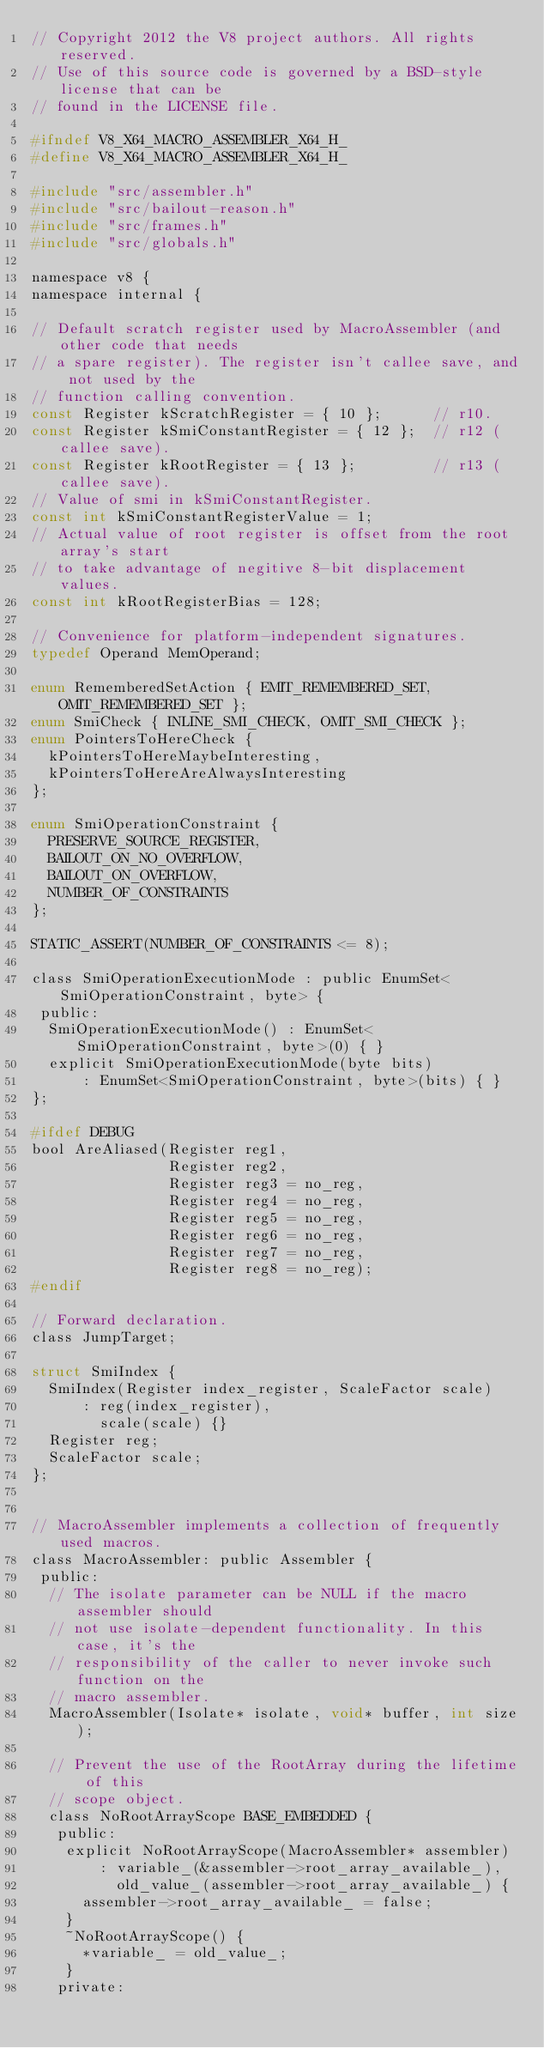Convert code to text. <code><loc_0><loc_0><loc_500><loc_500><_C_>// Copyright 2012 the V8 project authors. All rights reserved.
// Use of this source code is governed by a BSD-style license that can be
// found in the LICENSE file.

#ifndef V8_X64_MACRO_ASSEMBLER_X64_H_
#define V8_X64_MACRO_ASSEMBLER_X64_H_

#include "src/assembler.h"
#include "src/bailout-reason.h"
#include "src/frames.h"
#include "src/globals.h"

namespace v8 {
namespace internal {

// Default scratch register used by MacroAssembler (and other code that needs
// a spare register). The register isn't callee save, and not used by the
// function calling convention.
const Register kScratchRegister = { 10 };      // r10.
const Register kSmiConstantRegister = { 12 };  // r12 (callee save).
const Register kRootRegister = { 13 };         // r13 (callee save).
// Value of smi in kSmiConstantRegister.
const int kSmiConstantRegisterValue = 1;
// Actual value of root register is offset from the root array's start
// to take advantage of negitive 8-bit displacement values.
const int kRootRegisterBias = 128;

// Convenience for platform-independent signatures.
typedef Operand MemOperand;

enum RememberedSetAction { EMIT_REMEMBERED_SET, OMIT_REMEMBERED_SET };
enum SmiCheck { INLINE_SMI_CHECK, OMIT_SMI_CHECK };
enum PointersToHereCheck {
  kPointersToHereMaybeInteresting,
  kPointersToHereAreAlwaysInteresting
};

enum SmiOperationConstraint {
  PRESERVE_SOURCE_REGISTER,
  BAILOUT_ON_NO_OVERFLOW,
  BAILOUT_ON_OVERFLOW,
  NUMBER_OF_CONSTRAINTS
};

STATIC_ASSERT(NUMBER_OF_CONSTRAINTS <= 8);

class SmiOperationExecutionMode : public EnumSet<SmiOperationConstraint, byte> {
 public:
  SmiOperationExecutionMode() : EnumSet<SmiOperationConstraint, byte>(0) { }
  explicit SmiOperationExecutionMode(byte bits)
      : EnumSet<SmiOperationConstraint, byte>(bits) { }
};

#ifdef DEBUG
bool AreAliased(Register reg1,
                Register reg2,
                Register reg3 = no_reg,
                Register reg4 = no_reg,
                Register reg5 = no_reg,
                Register reg6 = no_reg,
                Register reg7 = no_reg,
                Register reg8 = no_reg);
#endif

// Forward declaration.
class JumpTarget;

struct SmiIndex {
  SmiIndex(Register index_register, ScaleFactor scale)
      : reg(index_register),
        scale(scale) {}
  Register reg;
  ScaleFactor scale;
};


// MacroAssembler implements a collection of frequently used macros.
class MacroAssembler: public Assembler {
 public:
  // The isolate parameter can be NULL if the macro assembler should
  // not use isolate-dependent functionality. In this case, it's the
  // responsibility of the caller to never invoke such function on the
  // macro assembler.
  MacroAssembler(Isolate* isolate, void* buffer, int size);

  // Prevent the use of the RootArray during the lifetime of this
  // scope object.
  class NoRootArrayScope BASE_EMBEDDED {
   public:
    explicit NoRootArrayScope(MacroAssembler* assembler)
        : variable_(&assembler->root_array_available_),
          old_value_(assembler->root_array_available_) {
      assembler->root_array_available_ = false;
    }
    ~NoRootArrayScope() {
      *variable_ = old_value_;
    }
   private:</code> 